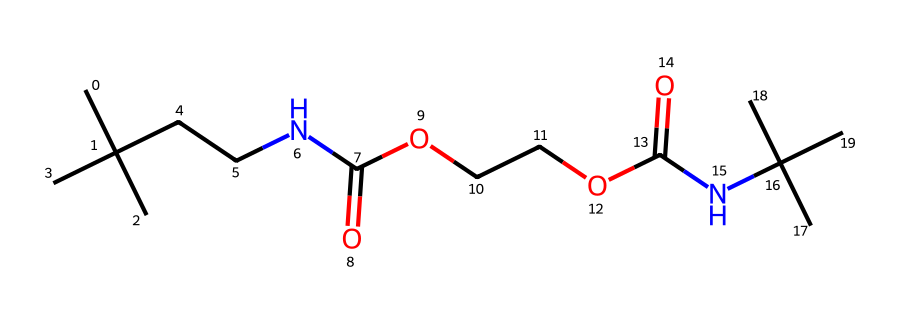How many carbon atoms are present in this structure? By analyzing the SMILES representation, we count the 'C' characters. Each 'C' represents a carbon atom. There are a total of 10 'C' noted, indicating there are 10 carbon atoms in the structure.
Answer: 10 What functional groups are present in this polyurethane structure? In the SMILES, we can identify the presence of ester groups (indicated by 'C(=O)O') and amine groups (indicated by 'NC'). These functional groups are characteristic of polyurethane.
Answer: ester and amine What is the degree of branching observed in this polymer? The branched structure can be identified by the presence of tertiary carbon atoms (like those connected to the amine groups). By assessing the structure, we find that this polymer exhibits a high degree of branching due to multiple branching points in its carbon framework.
Answer: high Which part of this chemical contributes to its flexibility? The presence of flexible segments often correlates to large, aliphatic chains in polymers. Here, the multiple carbon chains, especially those linking the amine and ester functional groups, contribute to the overall flexibility.
Answer: aliphatic chains What is the total number of nitrogen atoms in this chemical? In the provided SMILES representation, every 'N' indicates a nitrogen atom. By counting the 'N' characters, we find that there are 2 nitrogen atoms present in the structure.
Answer: 2 Regarding the thermal stability of this polyurethane, what factors contribute? Thermal stability in polymers like polyurethane is influenced by the molecular weight and the presence of crosslinking. This structure indicates that the arrangement of esters and amines likely leads to increased thermal stability, contributing to its resistance against heat.
Answer: crosslinking What type of polymerization could be involved in the synthesis of this polyurethane? Given the presence of functional groups and their ability to react, the polymerization is likely a step-growth polymerization (also called condensation polymerization), typical for polyurethanes which join diisocyanates with polyols.
Answer: step-growth 